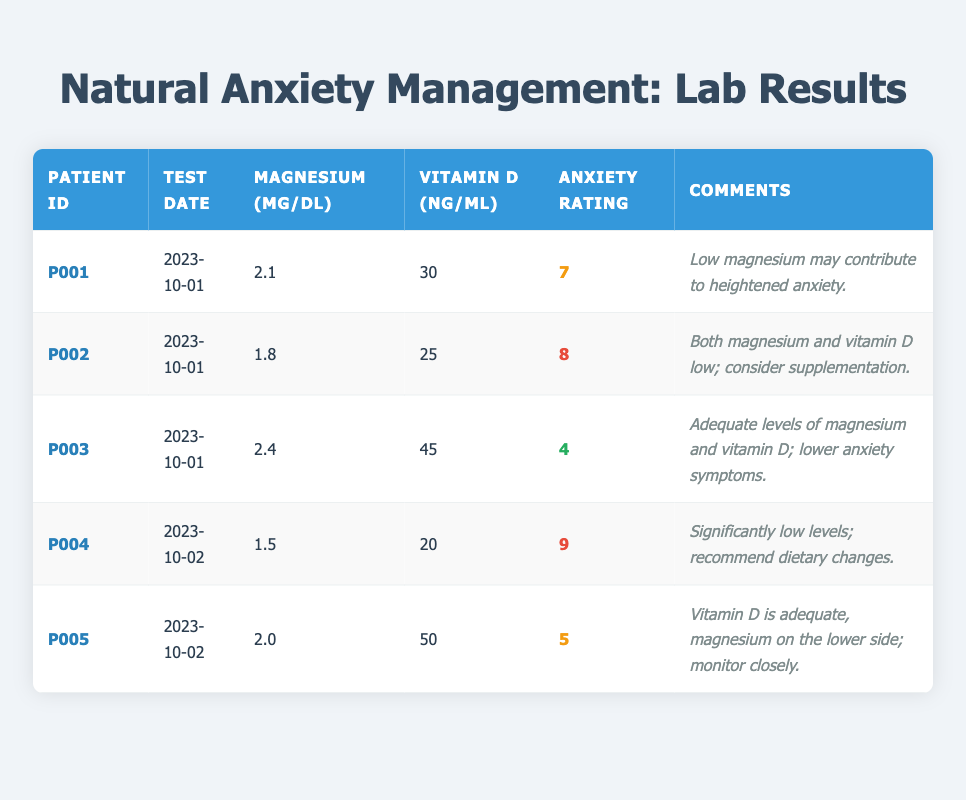What is the magnesium level for patient P003? The table indicates that patient P003 has a magnesium level of 2.4 mg/dL, as shown in the corresponding cell under the magnesium column.
Answer: 2.4 mg/dL How many patients have a vitamin D level below 30 ng/mL? By reviewing the vitamin D levels in the table, patients P002, P004, and P001 have values below 30 ng/mL (25, 20, and 30 respectively). This gives a total of 3 patients.
Answer: 3 patients What is the average anxiety symptoms rating for patients with magnesium levels below 2.0 mg/dL? The relevant patients with magnesium levels below 2.0 mg/dL are P002 (8) and P004 (9). To find the average, sum the ratings (8 + 9 = 17) and divide by the number of patients (2), leading to an average anxiety rating of 17/2 = 8.5.
Answer: 8.5 Is patient P005 experiencing high anxiety symptoms based on their rating? Looking at the anxiety symptoms rating for patient P005, which is 5, we notice that this rating classifies as medium anxiety (less than 7). Hence, it is false to say they are experiencing high anxiety.
Answer: No Which patient has the lowest anxiety symptoms rating and what are their magnesium and vitamin D levels? Patient P003 has the lowest anxiety symptoms rating of 4. For their magnesium level, it is 2.4 mg/dL and their vitamin D level is 45 ng/mL.
Answer: Patient P003, Magnesium: 2.4 mg/dL, Vitamin D: 45 ng/mL How does the anxiety rating correlate with magnesium levels for the patients tested? Observing the trends in the table, patients with lower magnesium (P001, P002, P004) tend to have higher anxiety ratings (7, 8, 9 respectively). P003 and P005, who have higher magnesium levels, present with lower anxiety ratings (4 and 5 respectively). Thus, a possible correlation suggests that lower magnesium may be linked with increased anxiety.
Answer: Patients with lower magnesium have higher anxiety ratings What recommendation is given for patient P002 based on their lab results? The comments for patient P002 indicate that both magnesium and vitamin D are low, and it is suggested they consider supplementation to address these deficiencies.
Answer: Consider supplementation Are there any patients that have adequate levels of both magnesium and vitamin D? By checking the table, patient P003 shows adequate levels for both minerals (2.4 mg/dL magnesium and 45 ng/mL vitamin D), confirming that there is at least one patient meeting this criterion.
Answer: Yes, patient P003 